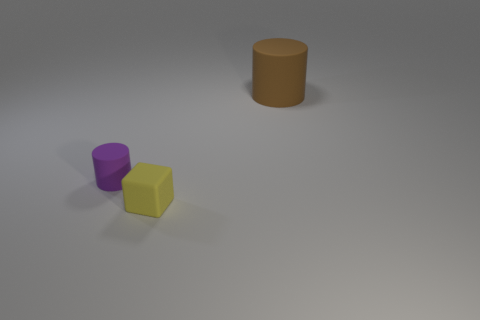How many objects are both behind the yellow object and on the right side of the small purple rubber cylinder?
Give a very brief answer. 1. Are there any other things that have the same color as the tiny rubber block?
Offer a very short reply. No. How many shiny objects are cubes or large objects?
Your response must be concise. 0. What material is the cylinder on the left side of the cylinder that is behind the tiny object that is to the left of the yellow cube made of?
Make the answer very short. Rubber. What material is the small object in front of the purple rubber thing that is behind the yellow thing?
Your response must be concise. Rubber. There is a rubber cylinder on the left side of the matte block; does it have the same size as the matte cylinder behind the purple matte thing?
Your response must be concise. No. Is there anything else that is made of the same material as the big object?
Give a very brief answer. Yes. What number of large things are either yellow objects or green metal balls?
Make the answer very short. 0. What number of things are either cylinders in front of the big rubber cylinder or yellow blocks?
Provide a succinct answer. 2. Is the tiny matte cube the same color as the large matte cylinder?
Offer a terse response. No. 